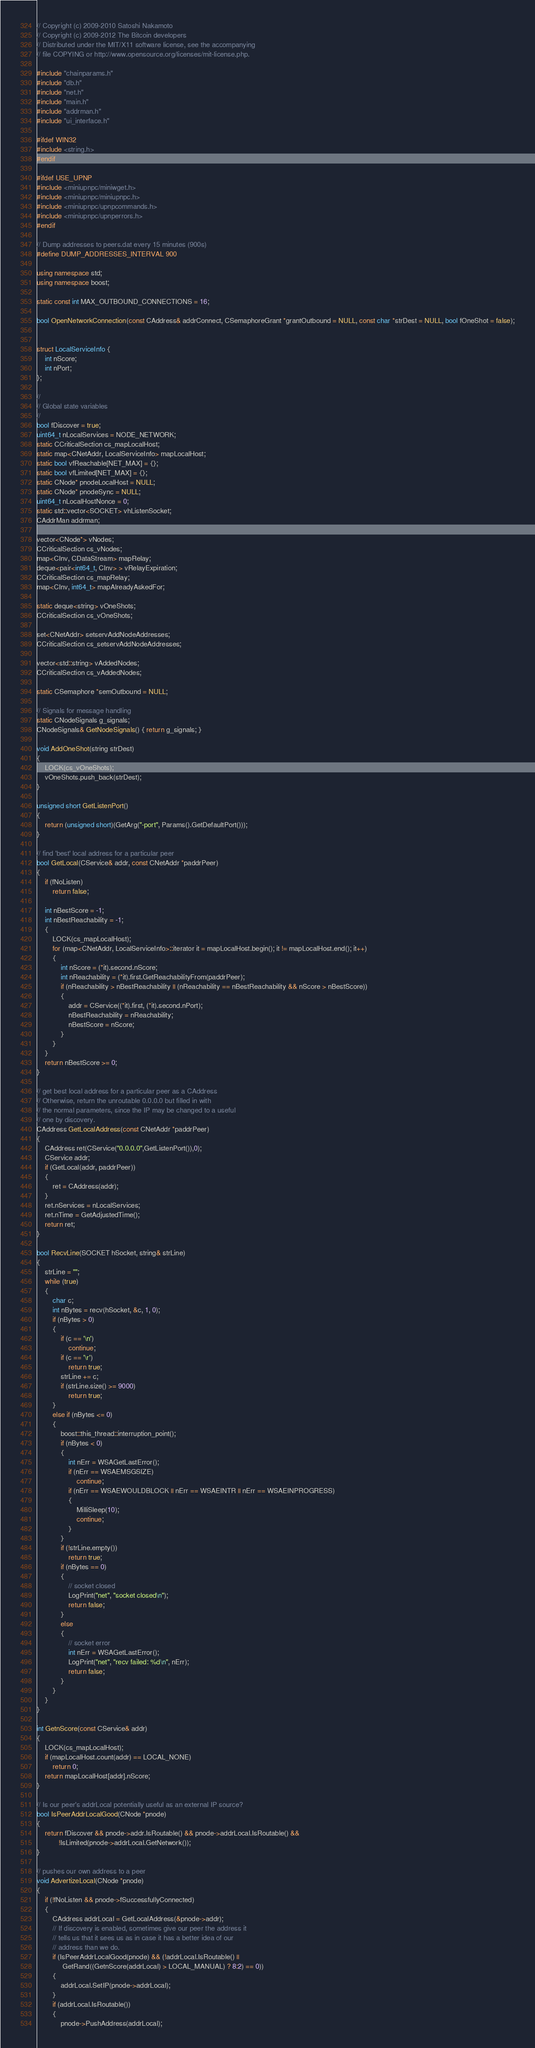<code> <loc_0><loc_0><loc_500><loc_500><_C++_>// Copyright (c) 2009-2010 Satoshi Nakamoto
// Copyright (c) 2009-2012 The Bitcoin developers
// Distributed under the MIT/X11 software license, see the accompanying
// file COPYING or http://www.opensource.org/licenses/mit-license.php.

#include "chainparams.h"
#include "db.h"
#include "net.h"
#include "main.h"
#include "addrman.h"
#include "ui_interface.h"

#ifdef WIN32
#include <string.h>
#endif

#ifdef USE_UPNP
#include <miniupnpc/miniwget.h>
#include <miniupnpc/miniupnpc.h>
#include <miniupnpc/upnpcommands.h>
#include <miniupnpc/upnperrors.h>
#endif

// Dump addresses to peers.dat every 15 minutes (900s)
#define DUMP_ADDRESSES_INTERVAL 900

using namespace std;
using namespace boost;

static const int MAX_OUTBOUND_CONNECTIONS = 16;

bool OpenNetworkConnection(const CAddress& addrConnect, CSemaphoreGrant *grantOutbound = NULL, const char *strDest = NULL, bool fOneShot = false);


struct LocalServiceInfo {
    int nScore;
    int nPort;
};

//
// Global state variables
//
bool fDiscover = true;
uint64_t nLocalServices = NODE_NETWORK;
static CCriticalSection cs_mapLocalHost;
static map<CNetAddr, LocalServiceInfo> mapLocalHost;
static bool vfReachable[NET_MAX] = {};
static bool vfLimited[NET_MAX] = {};
static CNode* pnodeLocalHost = NULL;
static CNode* pnodeSync = NULL;
uint64_t nLocalHostNonce = 0;
static std::vector<SOCKET> vhListenSocket;
CAddrMan addrman;

vector<CNode*> vNodes;
CCriticalSection cs_vNodes;
map<CInv, CDataStream> mapRelay;
deque<pair<int64_t, CInv> > vRelayExpiration;
CCriticalSection cs_mapRelay;
map<CInv, int64_t> mapAlreadyAskedFor;

static deque<string> vOneShots;
CCriticalSection cs_vOneShots;

set<CNetAddr> setservAddNodeAddresses;
CCriticalSection cs_setservAddNodeAddresses;

vector<std::string> vAddedNodes;
CCriticalSection cs_vAddedNodes;

static CSemaphore *semOutbound = NULL;

// Signals for message handling
static CNodeSignals g_signals;
CNodeSignals& GetNodeSignals() { return g_signals; }

void AddOneShot(string strDest)
{
    LOCK(cs_vOneShots);
    vOneShots.push_back(strDest);
}

unsigned short GetListenPort()
{
    return (unsigned short)(GetArg("-port", Params().GetDefaultPort()));
}

// find 'best' local address for a particular peer
bool GetLocal(CService& addr, const CNetAddr *paddrPeer)
{
    if (fNoListen)
        return false;

    int nBestScore = -1;
    int nBestReachability = -1;
    {
        LOCK(cs_mapLocalHost);
        for (map<CNetAddr, LocalServiceInfo>::iterator it = mapLocalHost.begin(); it != mapLocalHost.end(); it++)
        {
            int nScore = (*it).second.nScore;
            int nReachability = (*it).first.GetReachabilityFrom(paddrPeer);
            if (nReachability > nBestReachability || (nReachability == nBestReachability && nScore > nBestScore))
            {
                addr = CService((*it).first, (*it).second.nPort);
                nBestReachability = nReachability;
                nBestScore = nScore;
            }
        }
    }
    return nBestScore >= 0;
}

// get best local address for a particular peer as a CAddress
// Otherwise, return the unroutable 0.0.0.0 but filled in with
// the normal parameters, since the IP may be changed to a useful
// one by discovery.
CAddress GetLocalAddress(const CNetAddr *paddrPeer)
{
    CAddress ret(CService("0.0.0.0",GetListenPort()),0);
    CService addr;
    if (GetLocal(addr, paddrPeer))
    {
        ret = CAddress(addr);
    }
    ret.nServices = nLocalServices;
    ret.nTime = GetAdjustedTime();
    return ret;
}

bool RecvLine(SOCKET hSocket, string& strLine)
{
    strLine = "";
    while (true)
    {
        char c;
        int nBytes = recv(hSocket, &c, 1, 0);
        if (nBytes > 0)
        {
            if (c == '\n')
                continue;
            if (c == '\r')
                return true;
            strLine += c;
            if (strLine.size() >= 9000)
                return true;
        }
        else if (nBytes <= 0)
        {
            boost::this_thread::interruption_point();
            if (nBytes < 0)
            {
                int nErr = WSAGetLastError();
                if (nErr == WSAEMSGSIZE)
                    continue;
                if (nErr == WSAEWOULDBLOCK || nErr == WSAEINTR || nErr == WSAEINPROGRESS)
                {
                    MilliSleep(10);
                    continue;
                }
            }
            if (!strLine.empty())
                return true;
            if (nBytes == 0)
            {
                // socket closed
                LogPrint("net", "socket closed\n");
                return false;
            }
            else
            {
                // socket error
                int nErr = WSAGetLastError();
                LogPrint("net", "recv failed: %d\n", nErr);
                return false;
            }
        }
    }
}

int GetnScore(const CService& addr)
{
    LOCK(cs_mapLocalHost);
    if (mapLocalHost.count(addr) == LOCAL_NONE)
        return 0;
    return mapLocalHost[addr].nScore;
}

// Is our peer's addrLocal potentially useful as an external IP source?
bool IsPeerAddrLocalGood(CNode *pnode)
{
    return fDiscover && pnode->addr.IsRoutable() && pnode->addrLocal.IsRoutable() &&
           !IsLimited(pnode->addrLocal.GetNetwork());
}

// pushes our own address to a peer
void AdvertizeLocal(CNode *pnode)
{
    if (!fNoListen && pnode->fSuccessfullyConnected)
    {
        CAddress addrLocal = GetLocalAddress(&pnode->addr);
        // If discovery is enabled, sometimes give our peer the address it
        // tells us that it sees us as in case it has a better idea of our
        // address than we do.
        if (IsPeerAddrLocalGood(pnode) && (!addrLocal.IsRoutable() ||
             GetRand((GetnScore(addrLocal) > LOCAL_MANUAL) ? 8:2) == 0))
        {
            addrLocal.SetIP(pnode->addrLocal);
        }
        if (addrLocal.IsRoutable())
        {
            pnode->PushAddress(addrLocal);</code> 